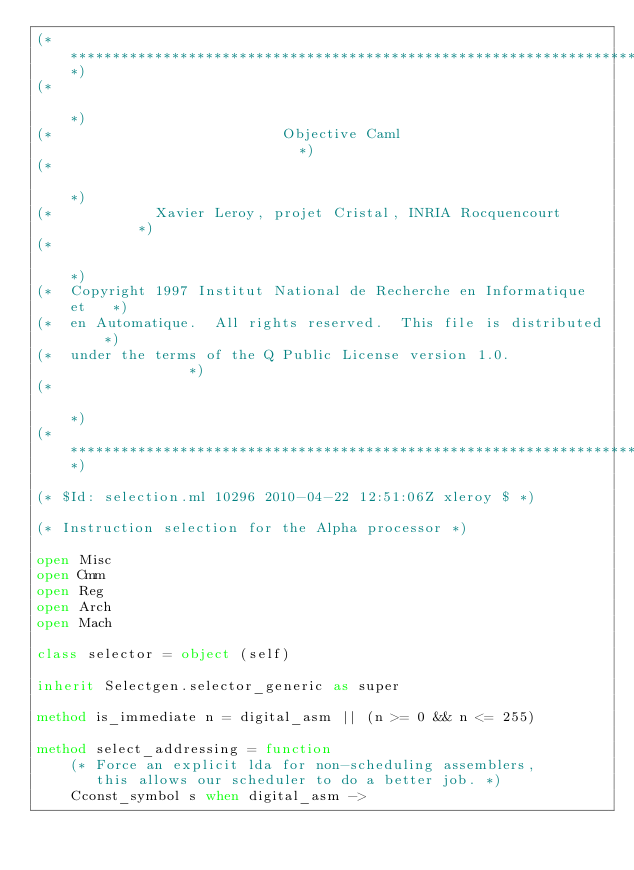Convert code to text. <code><loc_0><loc_0><loc_500><loc_500><_OCaml_>(***********************************************************************)
(*                                                                     *)
(*                           Objective Caml                            *)
(*                                                                     *)
(*            Xavier Leroy, projet Cristal, INRIA Rocquencourt         *)
(*                                                                     *)
(*  Copyright 1997 Institut National de Recherche en Informatique et   *)
(*  en Automatique.  All rights reserved.  This file is distributed    *)
(*  under the terms of the Q Public License version 1.0.               *)
(*                                                                     *)
(***********************************************************************)

(* $Id: selection.ml 10296 2010-04-22 12:51:06Z xleroy $ *)

(* Instruction selection for the Alpha processor *)

open Misc
open Cmm
open Reg
open Arch
open Mach

class selector = object (self)

inherit Selectgen.selector_generic as super

method is_immediate n = digital_asm || (n >= 0 && n <= 255)

method select_addressing = function
    (* Force an explicit lda for non-scheduling assemblers,
       this allows our scheduler to do a better job. *)
    Cconst_symbol s when digital_asm -></code> 